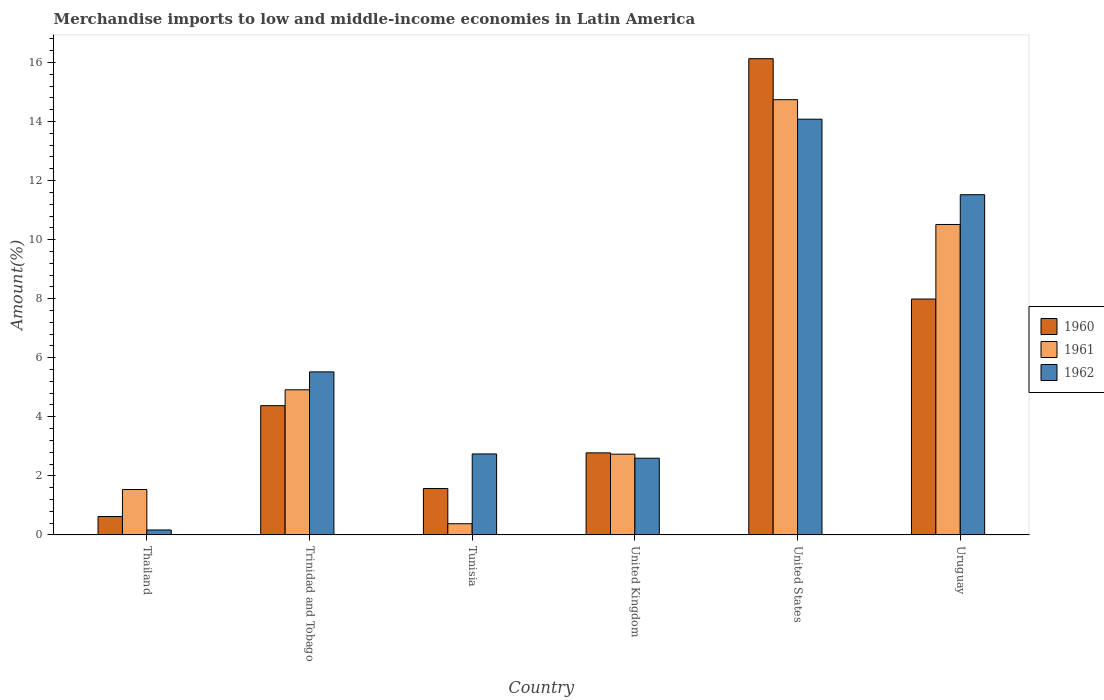How many different coloured bars are there?
Your response must be concise. 3. Are the number of bars per tick equal to the number of legend labels?
Your answer should be compact. Yes. Are the number of bars on each tick of the X-axis equal?
Make the answer very short. Yes. What is the label of the 3rd group of bars from the left?
Make the answer very short. Tunisia. What is the percentage of amount earned from merchandise imports in 1962 in United States?
Provide a short and direct response. 14.08. Across all countries, what is the maximum percentage of amount earned from merchandise imports in 1962?
Your answer should be very brief. 14.08. Across all countries, what is the minimum percentage of amount earned from merchandise imports in 1962?
Provide a short and direct response. 0.17. In which country was the percentage of amount earned from merchandise imports in 1962 maximum?
Keep it short and to the point. United States. In which country was the percentage of amount earned from merchandise imports in 1962 minimum?
Provide a succinct answer. Thailand. What is the total percentage of amount earned from merchandise imports in 1961 in the graph?
Offer a very short reply. 34.82. What is the difference between the percentage of amount earned from merchandise imports in 1961 in Trinidad and Tobago and that in Uruguay?
Provide a succinct answer. -5.6. What is the difference between the percentage of amount earned from merchandise imports in 1960 in Thailand and the percentage of amount earned from merchandise imports in 1961 in Trinidad and Tobago?
Make the answer very short. -4.29. What is the average percentage of amount earned from merchandise imports in 1960 per country?
Ensure brevity in your answer.  5.58. What is the difference between the percentage of amount earned from merchandise imports of/in 1962 and percentage of amount earned from merchandise imports of/in 1960 in Trinidad and Tobago?
Provide a short and direct response. 1.14. What is the ratio of the percentage of amount earned from merchandise imports in 1962 in Tunisia to that in United Kingdom?
Offer a terse response. 1.06. Is the percentage of amount earned from merchandise imports in 1961 in Tunisia less than that in Uruguay?
Your response must be concise. Yes. What is the difference between the highest and the second highest percentage of amount earned from merchandise imports in 1961?
Provide a short and direct response. 5.6. What is the difference between the highest and the lowest percentage of amount earned from merchandise imports in 1960?
Ensure brevity in your answer.  15.51. In how many countries, is the percentage of amount earned from merchandise imports in 1961 greater than the average percentage of amount earned from merchandise imports in 1961 taken over all countries?
Your response must be concise. 2. What does the 3rd bar from the left in United States represents?
Offer a terse response. 1962. What does the 3rd bar from the right in Uruguay represents?
Your answer should be compact. 1960. How many bars are there?
Your answer should be very brief. 18. Are all the bars in the graph horizontal?
Your answer should be compact. No. What is the difference between two consecutive major ticks on the Y-axis?
Provide a succinct answer. 2. Where does the legend appear in the graph?
Offer a very short reply. Center right. How many legend labels are there?
Offer a terse response. 3. How are the legend labels stacked?
Make the answer very short. Vertical. What is the title of the graph?
Make the answer very short. Merchandise imports to low and middle-income economies in Latin America. What is the label or title of the Y-axis?
Keep it short and to the point. Amount(%). What is the Amount(%) of 1960 in Thailand?
Offer a very short reply. 0.62. What is the Amount(%) in 1961 in Thailand?
Your response must be concise. 1.54. What is the Amount(%) of 1962 in Thailand?
Provide a succinct answer. 0.17. What is the Amount(%) in 1960 in Trinidad and Tobago?
Provide a succinct answer. 4.38. What is the Amount(%) of 1961 in Trinidad and Tobago?
Your response must be concise. 4.92. What is the Amount(%) of 1962 in Trinidad and Tobago?
Provide a short and direct response. 5.52. What is the Amount(%) in 1960 in Tunisia?
Provide a succinct answer. 1.57. What is the Amount(%) in 1961 in Tunisia?
Your answer should be very brief. 0.38. What is the Amount(%) of 1962 in Tunisia?
Your response must be concise. 2.74. What is the Amount(%) in 1960 in United Kingdom?
Ensure brevity in your answer.  2.78. What is the Amount(%) in 1961 in United Kingdom?
Provide a succinct answer. 2.73. What is the Amount(%) in 1962 in United Kingdom?
Your answer should be compact. 2.6. What is the Amount(%) in 1960 in United States?
Your answer should be very brief. 16.13. What is the Amount(%) of 1961 in United States?
Your response must be concise. 14.74. What is the Amount(%) of 1962 in United States?
Ensure brevity in your answer.  14.08. What is the Amount(%) of 1960 in Uruguay?
Offer a very short reply. 7.99. What is the Amount(%) of 1961 in Uruguay?
Provide a short and direct response. 10.51. What is the Amount(%) of 1962 in Uruguay?
Ensure brevity in your answer.  11.52. Across all countries, what is the maximum Amount(%) of 1960?
Provide a short and direct response. 16.13. Across all countries, what is the maximum Amount(%) in 1961?
Ensure brevity in your answer.  14.74. Across all countries, what is the maximum Amount(%) of 1962?
Provide a succinct answer. 14.08. Across all countries, what is the minimum Amount(%) of 1960?
Make the answer very short. 0.62. Across all countries, what is the minimum Amount(%) of 1961?
Give a very brief answer. 0.38. Across all countries, what is the minimum Amount(%) of 1962?
Give a very brief answer. 0.17. What is the total Amount(%) in 1960 in the graph?
Your answer should be compact. 33.47. What is the total Amount(%) of 1961 in the graph?
Your answer should be compact. 34.82. What is the total Amount(%) of 1962 in the graph?
Ensure brevity in your answer.  36.63. What is the difference between the Amount(%) in 1960 in Thailand and that in Trinidad and Tobago?
Offer a terse response. -3.76. What is the difference between the Amount(%) in 1961 in Thailand and that in Trinidad and Tobago?
Make the answer very short. -3.38. What is the difference between the Amount(%) of 1962 in Thailand and that in Trinidad and Tobago?
Offer a terse response. -5.35. What is the difference between the Amount(%) of 1960 in Thailand and that in Tunisia?
Keep it short and to the point. -0.95. What is the difference between the Amount(%) in 1961 in Thailand and that in Tunisia?
Offer a terse response. 1.16. What is the difference between the Amount(%) in 1962 in Thailand and that in Tunisia?
Your response must be concise. -2.58. What is the difference between the Amount(%) in 1960 in Thailand and that in United Kingdom?
Offer a very short reply. -2.16. What is the difference between the Amount(%) in 1961 in Thailand and that in United Kingdom?
Keep it short and to the point. -1.2. What is the difference between the Amount(%) in 1962 in Thailand and that in United Kingdom?
Provide a succinct answer. -2.43. What is the difference between the Amount(%) of 1960 in Thailand and that in United States?
Keep it short and to the point. -15.51. What is the difference between the Amount(%) in 1961 in Thailand and that in United States?
Your answer should be very brief. -13.2. What is the difference between the Amount(%) in 1962 in Thailand and that in United States?
Keep it short and to the point. -13.91. What is the difference between the Amount(%) of 1960 in Thailand and that in Uruguay?
Ensure brevity in your answer.  -7.37. What is the difference between the Amount(%) in 1961 in Thailand and that in Uruguay?
Your response must be concise. -8.98. What is the difference between the Amount(%) in 1962 in Thailand and that in Uruguay?
Offer a very short reply. -11.36. What is the difference between the Amount(%) of 1960 in Trinidad and Tobago and that in Tunisia?
Make the answer very short. 2.81. What is the difference between the Amount(%) in 1961 in Trinidad and Tobago and that in Tunisia?
Your answer should be compact. 4.54. What is the difference between the Amount(%) in 1962 in Trinidad and Tobago and that in Tunisia?
Your answer should be very brief. 2.78. What is the difference between the Amount(%) of 1960 in Trinidad and Tobago and that in United Kingdom?
Make the answer very short. 1.6. What is the difference between the Amount(%) of 1961 in Trinidad and Tobago and that in United Kingdom?
Provide a succinct answer. 2.18. What is the difference between the Amount(%) in 1962 in Trinidad and Tobago and that in United Kingdom?
Ensure brevity in your answer.  2.92. What is the difference between the Amount(%) of 1960 in Trinidad and Tobago and that in United States?
Your response must be concise. -11.75. What is the difference between the Amount(%) in 1961 in Trinidad and Tobago and that in United States?
Provide a succinct answer. -9.83. What is the difference between the Amount(%) in 1962 in Trinidad and Tobago and that in United States?
Provide a succinct answer. -8.56. What is the difference between the Amount(%) of 1960 in Trinidad and Tobago and that in Uruguay?
Provide a succinct answer. -3.61. What is the difference between the Amount(%) in 1961 in Trinidad and Tobago and that in Uruguay?
Your answer should be compact. -5.6. What is the difference between the Amount(%) of 1962 in Trinidad and Tobago and that in Uruguay?
Give a very brief answer. -6. What is the difference between the Amount(%) of 1960 in Tunisia and that in United Kingdom?
Your answer should be very brief. -1.21. What is the difference between the Amount(%) in 1961 in Tunisia and that in United Kingdom?
Your answer should be very brief. -2.36. What is the difference between the Amount(%) in 1962 in Tunisia and that in United Kingdom?
Offer a terse response. 0.15. What is the difference between the Amount(%) in 1960 in Tunisia and that in United States?
Make the answer very short. -14.56. What is the difference between the Amount(%) of 1961 in Tunisia and that in United States?
Provide a succinct answer. -14.36. What is the difference between the Amount(%) in 1962 in Tunisia and that in United States?
Ensure brevity in your answer.  -11.34. What is the difference between the Amount(%) in 1960 in Tunisia and that in Uruguay?
Keep it short and to the point. -6.42. What is the difference between the Amount(%) of 1961 in Tunisia and that in Uruguay?
Your response must be concise. -10.14. What is the difference between the Amount(%) of 1962 in Tunisia and that in Uruguay?
Your answer should be very brief. -8.78. What is the difference between the Amount(%) in 1960 in United Kingdom and that in United States?
Provide a succinct answer. -13.35. What is the difference between the Amount(%) in 1961 in United Kingdom and that in United States?
Provide a succinct answer. -12.01. What is the difference between the Amount(%) in 1962 in United Kingdom and that in United States?
Your response must be concise. -11.48. What is the difference between the Amount(%) of 1960 in United Kingdom and that in Uruguay?
Give a very brief answer. -5.21. What is the difference between the Amount(%) in 1961 in United Kingdom and that in Uruguay?
Keep it short and to the point. -7.78. What is the difference between the Amount(%) of 1962 in United Kingdom and that in Uruguay?
Offer a terse response. -8.93. What is the difference between the Amount(%) in 1960 in United States and that in Uruguay?
Make the answer very short. 8.14. What is the difference between the Amount(%) of 1961 in United States and that in Uruguay?
Provide a succinct answer. 4.23. What is the difference between the Amount(%) in 1962 in United States and that in Uruguay?
Give a very brief answer. 2.56. What is the difference between the Amount(%) of 1960 in Thailand and the Amount(%) of 1961 in Trinidad and Tobago?
Give a very brief answer. -4.29. What is the difference between the Amount(%) of 1960 in Thailand and the Amount(%) of 1962 in Trinidad and Tobago?
Give a very brief answer. -4.9. What is the difference between the Amount(%) of 1961 in Thailand and the Amount(%) of 1962 in Trinidad and Tobago?
Give a very brief answer. -3.98. What is the difference between the Amount(%) of 1960 in Thailand and the Amount(%) of 1961 in Tunisia?
Provide a succinct answer. 0.24. What is the difference between the Amount(%) in 1960 in Thailand and the Amount(%) in 1962 in Tunisia?
Provide a succinct answer. -2.12. What is the difference between the Amount(%) of 1961 in Thailand and the Amount(%) of 1962 in Tunisia?
Make the answer very short. -1.2. What is the difference between the Amount(%) of 1960 in Thailand and the Amount(%) of 1961 in United Kingdom?
Give a very brief answer. -2.11. What is the difference between the Amount(%) in 1960 in Thailand and the Amount(%) in 1962 in United Kingdom?
Keep it short and to the point. -1.97. What is the difference between the Amount(%) in 1961 in Thailand and the Amount(%) in 1962 in United Kingdom?
Ensure brevity in your answer.  -1.06. What is the difference between the Amount(%) of 1960 in Thailand and the Amount(%) of 1961 in United States?
Make the answer very short. -14.12. What is the difference between the Amount(%) of 1960 in Thailand and the Amount(%) of 1962 in United States?
Offer a very short reply. -13.46. What is the difference between the Amount(%) in 1961 in Thailand and the Amount(%) in 1962 in United States?
Provide a succinct answer. -12.54. What is the difference between the Amount(%) of 1960 in Thailand and the Amount(%) of 1961 in Uruguay?
Provide a succinct answer. -9.89. What is the difference between the Amount(%) of 1960 in Thailand and the Amount(%) of 1962 in Uruguay?
Ensure brevity in your answer.  -10.9. What is the difference between the Amount(%) of 1961 in Thailand and the Amount(%) of 1962 in Uruguay?
Keep it short and to the point. -9.98. What is the difference between the Amount(%) in 1960 in Trinidad and Tobago and the Amount(%) in 1961 in Tunisia?
Offer a very short reply. 4. What is the difference between the Amount(%) of 1960 in Trinidad and Tobago and the Amount(%) of 1962 in Tunisia?
Offer a very short reply. 1.64. What is the difference between the Amount(%) of 1961 in Trinidad and Tobago and the Amount(%) of 1962 in Tunisia?
Offer a terse response. 2.17. What is the difference between the Amount(%) of 1960 in Trinidad and Tobago and the Amount(%) of 1961 in United Kingdom?
Your answer should be very brief. 1.64. What is the difference between the Amount(%) of 1960 in Trinidad and Tobago and the Amount(%) of 1962 in United Kingdom?
Your answer should be compact. 1.78. What is the difference between the Amount(%) of 1961 in Trinidad and Tobago and the Amount(%) of 1962 in United Kingdom?
Keep it short and to the point. 2.32. What is the difference between the Amount(%) in 1960 in Trinidad and Tobago and the Amount(%) in 1961 in United States?
Provide a short and direct response. -10.36. What is the difference between the Amount(%) of 1960 in Trinidad and Tobago and the Amount(%) of 1962 in United States?
Your response must be concise. -9.7. What is the difference between the Amount(%) of 1961 in Trinidad and Tobago and the Amount(%) of 1962 in United States?
Provide a short and direct response. -9.16. What is the difference between the Amount(%) of 1960 in Trinidad and Tobago and the Amount(%) of 1961 in Uruguay?
Make the answer very short. -6.14. What is the difference between the Amount(%) of 1960 in Trinidad and Tobago and the Amount(%) of 1962 in Uruguay?
Offer a very short reply. -7.14. What is the difference between the Amount(%) in 1961 in Trinidad and Tobago and the Amount(%) in 1962 in Uruguay?
Keep it short and to the point. -6.61. What is the difference between the Amount(%) of 1960 in Tunisia and the Amount(%) of 1961 in United Kingdom?
Ensure brevity in your answer.  -1.16. What is the difference between the Amount(%) in 1960 in Tunisia and the Amount(%) in 1962 in United Kingdom?
Your answer should be compact. -1.03. What is the difference between the Amount(%) in 1961 in Tunisia and the Amount(%) in 1962 in United Kingdom?
Ensure brevity in your answer.  -2.22. What is the difference between the Amount(%) of 1960 in Tunisia and the Amount(%) of 1961 in United States?
Ensure brevity in your answer.  -13.17. What is the difference between the Amount(%) of 1960 in Tunisia and the Amount(%) of 1962 in United States?
Offer a very short reply. -12.51. What is the difference between the Amount(%) of 1961 in Tunisia and the Amount(%) of 1962 in United States?
Your answer should be very brief. -13.7. What is the difference between the Amount(%) in 1960 in Tunisia and the Amount(%) in 1961 in Uruguay?
Provide a succinct answer. -8.94. What is the difference between the Amount(%) of 1960 in Tunisia and the Amount(%) of 1962 in Uruguay?
Ensure brevity in your answer.  -9.95. What is the difference between the Amount(%) of 1961 in Tunisia and the Amount(%) of 1962 in Uruguay?
Make the answer very short. -11.14. What is the difference between the Amount(%) in 1960 in United Kingdom and the Amount(%) in 1961 in United States?
Offer a very short reply. -11.96. What is the difference between the Amount(%) of 1960 in United Kingdom and the Amount(%) of 1962 in United States?
Make the answer very short. -11.3. What is the difference between the Amount(%) in 1961 in United Kingdom and the Amount(%) in 1962 in United States?
Offer a terse response. -11.35. What is the difference between the Amount(%) of 1960 in United Kingdom and the Amount(%) of 1961 in Uruguay?
Your answer should be compact. -7.74. What is the difference between the Amount(%) in 1960 in United Kingdom and the Amount(%) in 1962 in Uruguay?
Ensure brevity in your answer.  -8.74. What is the difference between the Amount(%) in 1961 in United Kingdom and the Amount(%) in 1962 in Uruguay?
Make the answer very short. -8.79. What is the difference between the Amount(%) of 1960 in United States and the Amount(%) of 1961 in Uruguay?
Offer a terse response. 5.62. What is the difference between the Amount(%) in 1960 in United States and the Amount(%) in 1962 in Uruguay?
Provide a succinct answer. 4.61. What is the difference between the Amount(%) in 1961 in United States and the Amount(%) in 1962 in Uruguay?
Offer a very short reply. 3.22. What is the average Amount(%) of 1960 per country?
Your answer should be compact. 5.58. What is the average Amount(%) in 1961 per country?
Give a very brief answer. 5.8. What is the average Amount(%) in 1962 per country?
Provide a short and direct response. 6.1. What is the difference between the Amount(%) in 1960 and Amount(%) in 1961 in Thailand?
Keep it short and to the point. -0.92. What is the difference between the Amount(%) in 1960 and Amount(%) in 1962 in Thailand?
Give a very brief answer. 0.46. What is the difference between the Amount(%) of 1961 and Amount(%) of 1962 in Thailand?
Your answer should be compact. 1.37. What is the difference between the Amount(%) in 1960 and Amount(%) in 1961 in Trinidad and Tobago?
Give a very brief answer. -0.54. What is the difference between the Amount(%) of 1960 and Amount(%) of 1962 in Trinidad and Tobago?
Your answer should be compact. -1.14. What is the difference between the Amount(%) of 1961 and Amount(%) of 1962 in Trinidad and Tobago?
Your answer should be compact. -0.61. What is the difference between the Amount(%) of 1960 and Amount(%) of 1961 in Tunisia?
Provide a succinct answer. 1.19. What is the difference between the Amount(%) of 1960 and Amount(%) of 1962 in Tunisia?
Offer a terse response. -1.17. What is the difference between the Amount(%) in 1961 and Amount(%) in 1962 in Tunisia?
Make the answer very short. -2.36. What is the difference between the Amount(%) of 1960 and Amount(%) of 1961 in United Kingdom?
Your response must be concise. 0.04. What is the difference between the Amount(%) of 1960 and Amount(%) of 1962 in United Kingdom?
Give a very brief answer. 0.18. What is the difference between the Amount(%) of 1961 and Amount(%) of 1962 in United Kingdom?
Offer a terse response. 0.14. What is the difference between the Amount(%) of 1960 and Amount(%) of 1961 in United States?
Your answer should be compact. 1.39. What is the difference between the Amount(%) of 1960 and Amount(%) of 1962 in United States?
Give a very brief answer. 2.05. What is the difference between the Amount(%) of 1961 and Amount(%) of 1962 in United States?
Ensure brevity in your answer.  0.66. What is the difference between the Amount(%) of 1960 and Amount(%) of 1961 in Uruguay?
Make the answer very short. -2.53. What is the difference between the Amount(%) of 1960 and Amount(%) of 1962 in Uruguay?
Your response must be concise. -3.53. What is the difference between the Amount(%) of 1961 and Amount(%) of 1962 in Uruguay?
Your answer should be very brief. -1.01. What is the ratio of the Amount(%) of 1960 in Thailand to that in Trinidad and Tobago?
Offer a terse response. 0.14. What is the ratio of the Amount(%) of 1961 in Thailand to that in Trinidad and Tobago?
Provide a succinct answer. 0.31. What is the ratio of the Amount(%) in 1962 in Thailand to that in Trinidad and Tobago?
Offer a terse response. 0.03. What is the ratio of the Amount(%) in 1960 in Thailand to that in Tunisia?
Your answer should be compact. 0.4. What is the ratio of the Amount(%) in 1961 in Thailand to that in Tunisia?
Offer a terse response. 4.06. What is the ratio of the Amount(%) of 1962 in Thailand to that in Tunisia?
Your answer should be compact. 0.06. What is the ratio of the Amount(%) of 1960 in Thailand to that in United Kingdom?
Offer a terse response. 0.22. What is the ratio of the Amount(%) in 1961 in Thailand to that in United Kingdom?
Offer a terse response. 0.56. What is the ratio of the Amount(%) in 1962 in Thailand to that in United Kingdom?
Offer a very short reply. 0.06. What is the ratio of the Amount(%) in 1960 in Thailand to that in United States?
Your response must be concise. 0.04. What is the ratio of the Amount(%) of 1961 in Thailand to that in United States?
Give a very brief answer. 0.1. What is the ratio of the Amount(%) of 1962 in Thailand to that in United States?
Make the answer very short. 0.01. What is the ratio of the Amount(%) in 1960 in Thailand to that in Uruguay?
Provide a short and direct response. 0.08. What is the ratio of the Amount(%) in 1961 in Thailand to that in Uruguay?
Keep it short and to the point. 0.15. What is the ratio of the Amount(%) of 1962 in Thailand to that in Uruguay?
Provide a short and direct response. 0.01. What is the ratio of the Amount(%) of 1960 in Trinidad and Tobago to that in Tunisia?
Provide a succinct answer. 2.79. What is the ratio of the Amount(%) of 1961 in Trinidad and Tobago to that in Tunisia?
Make the answer very short. 12.99. What is the ratio of the Amount(%) in 1962 in Trinidad and Tobago to that in Tunisia?
Make the answer very short. 2.01. What is the ratio of the Amount(%) in 1960 in Trinidad and Tobago to that in United Kingdom?
Offer a terse response. 1.58. What is the ratio of the Amount(%) in 1961 in Trinidad and Tobago to that in United Kingdom?
Your answer should be compact. 1.8. What is the ratio of the Amount(%) of 1962 in Trinidad and Tobago to that in United Kingdom?
Give a very brief answer. 2.13. What is the ratio of the Amount(%) in 1960 in Trinidad and Tobago to that in United States?
Provide a succinct answer. 0.27. What is the ratio of the Amount(%) in 1961 in Trinidad and Tobago to that in United States?
Your response must be concise. 0.33. What is the ratio of the Amount(%) of 1962 in Trinidad and Tobago to that in United States?
Give a very brief answer. 0.39. What is the ratio of the Amount(%) in 1960 in Trinidad and Tobago to that in Uruguay?
Keep it short and to the point. 0.55. What is the ratio of the Amount(%) in 1961 in Trinidad and Tobago to that in Uruguay?
Keep it short and to the point. 0.47. What is the ratio of the Amount(%) of 1962 in Trinidad and Tobago to that in Uruguay?
Ensure brevity in your answer.  0.48. What is the ratio of the Amount(%) of 1960 in Tunisia to that in United Kingdom?
Give a very brief answer. 0.57. What is the ratio of the Amount(%) in 1961 in Tunisia to that in United Kingdom?
Give a very brief answer. 0.14. What is the ratio of the Amount(%) of 1962 in Tunisia to that in United Kingdom?
Your response must be concise. 1.06. What is the ratio of the Amount(%) in 1960 in Tunisia to that in United States?
Offer a terse response. 0.1. What is the ratio of the Amount(%) of 1961 in Tunisia to that in United States?
Provide a short and direct response. 0.03. What is the ratio of the Amount(%) of 1962 in Tunisia to that in United States?
Offer a very short reply. 0.19. What is the ratio of the Amount(%) in 1960 in Tunisia to that in Uruguay?
Offer a very short reply. 0.2. What is the ratio of the Amount(%) of 1961 in Tunisia to that in Uruguay?
Your answer should be very brief. 0.04. What is the ratio of the Amount(%) in 1962 in Tunisia to that in Uruguay?
Offer a terse response. 0.24. What is the ratio of the Amount(%) of 1960 in United Kingdom to that in United States?
Give a very brief answer. 0.17. What is the ratio of the Amount(%) of 1961 in United Kingdom to that in United States?
Give a very brief answer. 0.19. What is the ratio of the Amount(%) of 1962 in United Kingdom to that in United States?
Provide a succinct answer. 0.18. What is the ratio of the Amount(%) in 1960 in United Kingdom to that in Uruguay?
Provide a short and direct response. 0.35. What is the ratio of the Amount(%) in 1961 in United Kingdom to that in Uruguay?
Keep it short and to the point. 0.26. What is the ratio of the Amount(%) of 1962 in United Kingdom to that in Uruguay?
Offer a very short reply. 0.23. What is the ratio of the Amount(%) in 1960 in United States to that in Uruguay?
Ensure brevity in your answer.  2.02. What is the ratio of the Amount(%) in 1961 in United States to that in Uruguay?
Your answer should be compact. 1.4. What is the ratio of the Amount(%) in 1962 in United States to that in Uruguay?
Provide a short and direct response. 1.22. What is the difference between the highest and the second highest Amount(%) of 1960?
Ensure brevity in your answer.  8.14. What is the difference between the highest and the second highest Amount(%) of 1961?
Your response must be concise. 4.23. What is the difference between the highest and the second highest Amount(%) of 1962?
Offer a terse response. 2.56. What is the difference between the highest and the lowest Amount(%) of 1960?
Make the answer very short. 15.51. What is the difference between the highest and the lowest Amount(%) of 1961?
Give a very brief answer. 14.36. What is the difference between the highest and the lowest Amount(%) of 1962?
Your response must be concise. 13.91. 